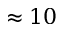<formula> <loc_0><loc_0><loc_500><loc_500>\approx 1 0</formula> 